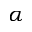<formula> <loc_0><loc_0><loc_500><loc_500>\alpha</formula> 